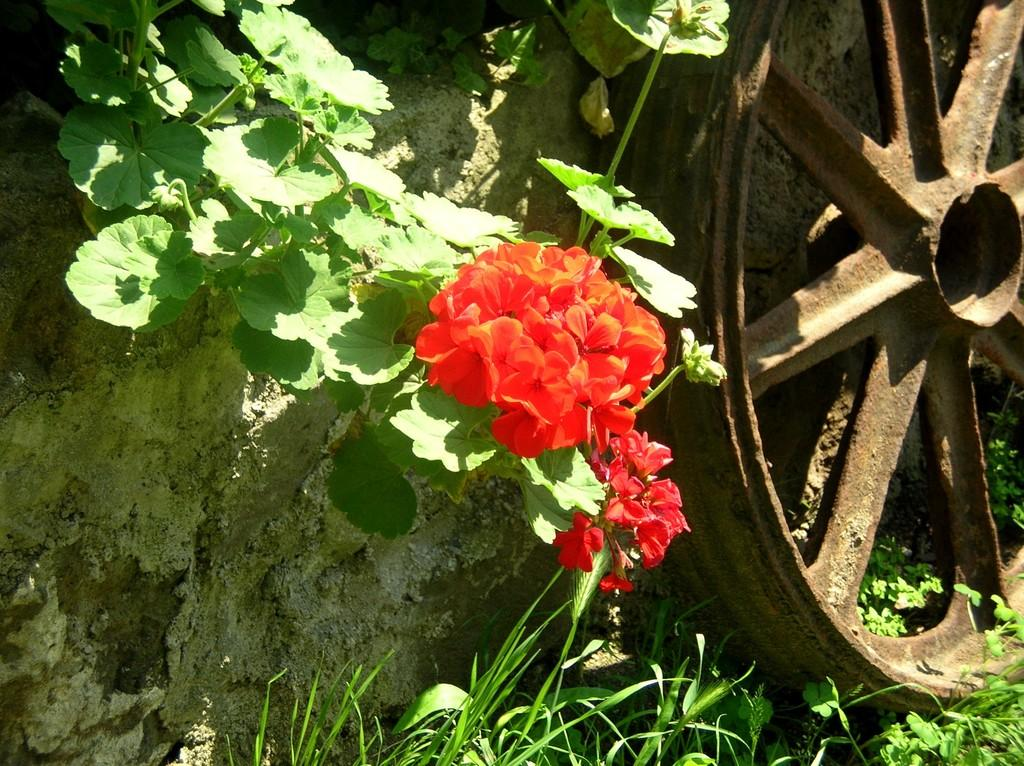What type of object is the metal wheel in the image? The metal wheel is a circular object made of metal. What other living organism can be seen in the image besides the metal wheel? There is a plant in the image. What additional feature can be observed on the plant? There are flowers on the plant. What type of books can be seen on the squirrel in the image? There is no squirrel or books present in the image. 